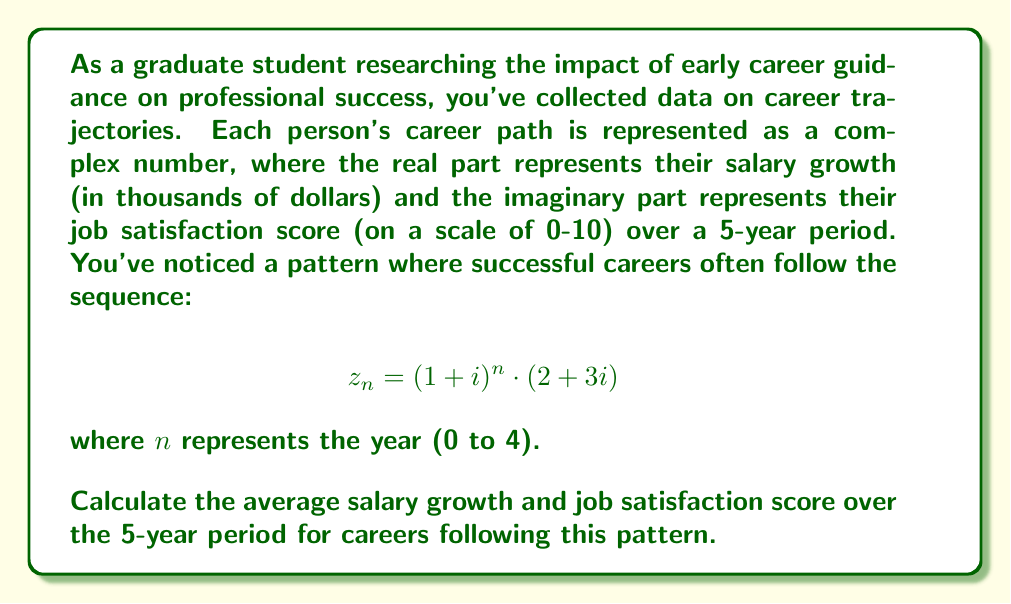Can you solve this math problem? To solve this problem, we need to follow these steps:

1) First, let's calculate $z_n$ for each year from 0 to 4:

   $z_0 = (1+i)^0 \cdot (2+3i) = 2+3i$
   $z_1 = (1+i)^1 \cdot (2+3i) = (1+i)(2+3i) = -1+5i$
   $z_2 = (1+i)^2 \cdot (2+3i) = (-2i)(2+3i) = 6-4i$
   $z_3 = (1+i)^3 \cdot (2+3i) = (-2-2i)(2+3i) = -10+1i$
   $z_4 = (1+i)^4 \cdot (2+3i) = (-4)(2+3i) = -8-12i$

2) Now, we need to sum up the real and imaginary parts separately:

   Real parts (salary growth): $2 + (-1) + 6 + (-10) + (-8) = -11$
   Imaginary parts (job satisfaction): $3 + 5 + (-4) + 1 + (-12) = -7$

3) To get the average, we divide each sum by 5 (the number of years):

   Average salary growth: $-11 / 5 = -2.2$
   Average job satisfaction: $-7 / 5 = -1.4$

4) Interpret the results:
   The average salary growth is -$2,200 per year.
   The average job satisfaction score is -1.4 on the 0-10 scale.
Answer: The average salary growth is -$2,200 per year, and the average job satisfaction score is -1.4 on the 0-10 scale. 